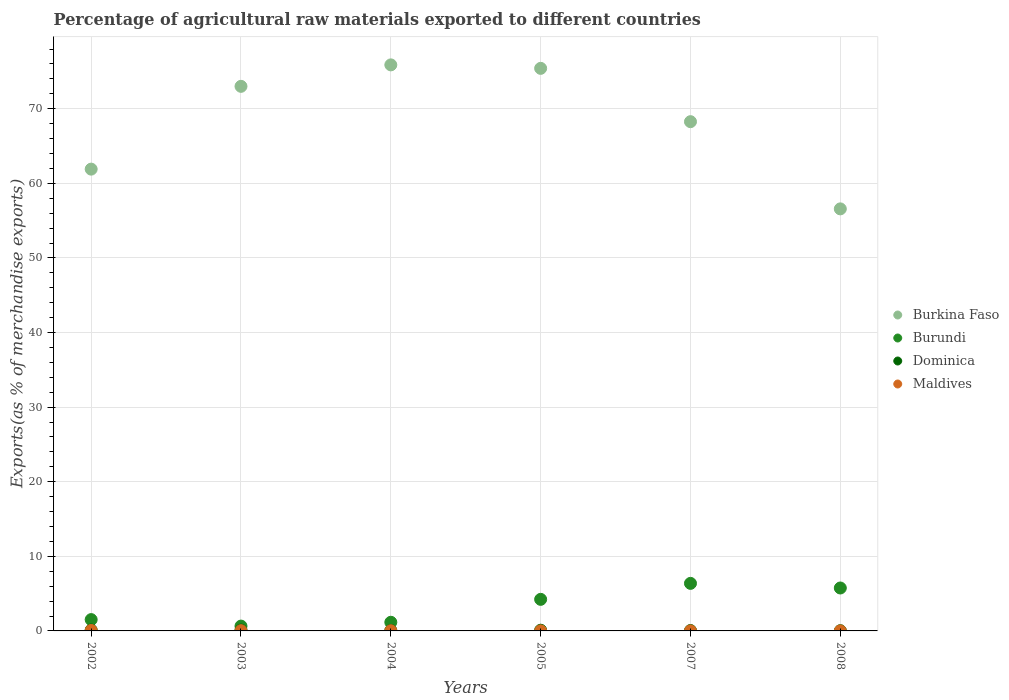What is the percentage of exports to different countries in Maldives in 2005?
Give a very brief answer. 0.01. Across all years, what is the maximum percentage of exports to different countries in Burundi?
Offer a very short reply. 6.37. Across all years, what is the minimum percentage of exports to different countries in Maldives?
Provide a succinct answer. 0. In which year was the percentage of exports to different countries in Maldives minimum?
Offer a terse response. 2008. What is the total percentage of exports to different countries in Burkina Faso in the graph?
Your answer should be very brief. 411.03. What is the difference between the percentage of exports to different countries in Dominica in 2003 and that in 2005?
Provide a succinct answer. 0.02. What is the difference between the percentage of exports to different countries in Burundi in 2004 and the percentage of exports to different countries in Dominica in 2008?
Provide a succinct answer. 1.13. What is the average percentage of exports to different countries in Burkina Faso per year?
Offer a very short reply. 68.51. In the year 2005, what is the difference between the percentage of exports to different countries in Dominica and percentage of exports to different countries in Maldives?
Provide a short and direct response. 0.09. What is the ratio of the percentage of exports to different countries in Maldives in 2005 to that in 2007?
Make the answer very short. 1.72. Is the percentage of exports to different countries in Burkina Faso in 2005 less than that in 2007?
Offer a terse response. No. What is the difference between the highest and the second highest percentage of exports to different countries in Burkina Faso?
Give a very brief answer. 0.47. What is the difference between the highest and the lowest percentage of exports to different countries in Dominica?
Offer a very short reply. 0.09. In how many years, is the percentage of exports to different countries in Burkina Faso greater than the average percentage of exports to different countries in Burkina Faso taken over all years?
Ensure brevity in your answer.  3. Is the sum of the percentage of exports to different countries in Maldives in 2002 and 2005 greater than the maximum percentage of exports to different countries in Dominica across all years?
Give a very brief answer. No. Is it the case that in every year, the sum of the percentage of exports to different countries in Burkina Faso and percentage of exports to different countries in Dominica  is greater than the sum of percentage of exports to different countries in Maldives and percentage of exports to different countries in Burundi?
Your answer should be compact. Yes. How many years are there in the graph?
Your response must be concise. 6. Does the graph contain any zero values?
Your response must be concise. No. Does the graph contain grids?
Give a very brief answer. Yes. Where does the legend appear in the graph?
Your response must be concise. Center right. What is the title of the graph?
Make the answer very short. Percentage of agricultural raw materials exported to different countries. What is the label or title of the Y-axis?
Your response must be concise. Exports(as % of merchandise exports). What is the Exports(as % of merchandise exports) of Burkina Faso in 2002?
Make the answer very short. 61.9. What is the Exports(as % of merchandise exports) of Burundi in 2002?
Ensure brevity in your answer.  1.52. What is the Exports(as % of merchandise exports) of Dominica in 2002?
Make the answer very short. 0.12. What is the Exports(as % of merchandise exports) in Maldives in 2002?
Offer a very short reply. 0.06. What is the Exports(as % of merchandise exports) of Burkina Faso in 2003?
Make the answer very short. 73. What is the Exports(as % of merchandise exports) in Burundi in 2003?
Offer a terse response. 0.65. What is the Exports(as % of merchandise exports) of Dominica in 2003?
Your response must be concise. 0.11. What is the Exports(as % of merchandise exports) of Maldives in 2003?
Offer a very short reply. 0.03. What is the Exports(as % of merchandise exports) in Burkina Faso in 2004?
Your answer should be very brief. 75.88. What is the Exports(as % of merchandise exports) of Burundi in 2004?
Ensure brevity in your answer.  1.16. What is the Exports(as % of merchandise exports) in Dominica in 2004?
Make the answer very short. 0.07. What is the Exports(as % of merchandise exports) in Maldives in 2004?
Make the answer very short. 0.03. What is the Exports(as % of merchandise exports) of Burkina Faso in 2005?
Provide a short and direct response. 75.41. What is the Exports(as % of merchandise exports) in Burundi in 2005?
Ensure brevity in your answer.  4.23. What is the Exports(as % of merchandise exports) of Dominica in 2005?
Provide a short and direct response. 0.09. What is the Exports(as % of merchandise exports) of Maldives in 2005?
Your answer should be very brief. 0.01. What is the Exports(as % of merchandise exports) in Burkina Faso in 2007?
Your answer should be compact. 68.26. What is the Exports(as % of merchandise exports) in Burundi in 2007?
Provide a succinct answer. 6.37. What is the Exports(as % of merchandise exports) of Dominica in 2007?
Your answer should be very brief. 0.05. What is the Exports(as % of merchandise exports) of Maldives in 2007?
Give a very brief answer. 0. What is the Exports(as % of merchandise exports) in Burkina Faso in 2008?
Give a very brief answer. 56.58. What is the Exports(as % of merchandise exports) in Burundi in 2008?
Your response must be concise. 5.75. What is the Exports(as % of merchandise exports) of Dominica in 2008?
Offer a terse response. 0.03. What is the Exports(as % of merchandise exports) of Maldives in 2008?
Provide a short and direct response. 0. Across all years, what is the maximum Exports(as % of merchandise exports) of Burkina Faso?
Your answer should be compact. 75.88. Across all years, what is the maximum Exports(as % of merchandise exports) in Burundi?
Your response must be concise. 6.37. Across all years, what is the maximum Exports(as % of merchandise exports) in Dominica?
Provide a succinct answer. 0.12. Across all years, what is the maximum Exports(as % of merchandise exports) in Maldives?
Provide a short and direct response. 0.06. Across all years, what is the minimum Exports(as % of merchandise exports) in Burkina Faso?
Your response must be concise. 56.58. Across all years, what is the minimum Exports(as % of merchandise exports) of Burundi?
Keep it short and to the point. 0.65. Across all years, what is the minimum Exports(as % of merchandise exports) in Dominica?
Your answer should be compact. 0.03. Across all years, what is the minimum Exports(as % of merchandise exports) in Maldives?
Ensure brevity in your answer.  0. What is the total Exports(as % of merchandise exports) in Burkina Faso in the graph?
Ensure brevity in your answer.  411.03. What is the total Exports(as % of merchandise exports) of Burundi in the graph?
Your answer should be very brief. 19.69. What is the total Exports(as % of merchandise exports) of Dominica in the graph?
Provide a succinct answer. 0.48. What is the total Exports(as % of merchandise exports) of Maldives in the graph?
Provide a short and direct response. 0.14. What is the difference between the Exports(as % of merchandise exports) in Burkina Faso in 2002 and that in 2003?
Keep it short and to the point. -11.1. What is the difference between the Exports(as % of merchandise exports) in Burundi in 2002 and that in 2003?
Your answer should be compact. 0.87. What is the difference between the Exports(as % of merchandise exports) in Dominica in 2002 and that in 2003?
Your answer should be compact. 0.01. What is the difference between the Exports(as % of merchandise exports) in Maldives in 2002 and that in 2003?
Your answer should be compact. 0.03. What is the difference between the Exports(as % of merchandise exports) in Burkina Faso in 2002 and that in 2004?
Make the answer very short. -13.98. What is the difference between the Exports(as % of merchandise exports) in Burundi in 2002 and that in 2004?
Your answer should be compact. 0.36. What is the difference between the Exports(as % of merchandise exports) of Dominica in 2002 and that in 2004?
Your response must be concise. 0.05. What is the difference between the Exports(as % of merchandise exports) of Maldives in 2002 and that in 2004?
Your answer should be very brief. 0.04. What is the difference between the Exports(as % of merchandise exports) in Burkina Faso in 2002 and that in 2005?
Offer a very short reply. -13.51. What is the difference between the Exports(as % of merchandise exports) in Burundi in 2002 and that in 2005?
Keep it short and to the point. -2.71. What is the difference between the Exports(as % of merchandise exports) in Dominica in 2002 and that in 2005?
Your answer should be compact. 0.03. What is the difference between the Exports(as % of merchandise exports) of Maldives in 2002 and that in 2005?
Offer a terse response. 0.06. What is the difference between the Exports(as % of merchandise exports) of Burkina Faso in 2002 and that in 2007?
Your answer should be compact. -6.36. What is the difference between the Exports(as % of merchandise exports) of Burundi in 2002 and that in 2007?
Offer a very short reply. -4.86. What is the difference between the Exports(as % of merchandise exports) in Dominica in 2002 and that in 2007?
Offer a terse response. 0.07. What is the difference between the Exports(as % of merchandise exports) of Maldives in 2002 and that in 2007?
Offer a terse response. 0.06. What is the difference between the Exports(as % of merchandise exports) in Burkina Faso in 2002 and that in 2008?
Provide a short and direct response. 5.33. What is the difference between the Exports(as % of merchandise exports) in Burundi in 2002 and that in 2008?
Provide a short and direct response. -4.24. What is the difference between the Exports(as % of merchandise exports) in Dominica in 2002 and that in 2008?
Give a very brief answer. 0.09. What is the difference between the Exports(as % of merchandise exports) of Maldives in 2002 and that in 2008?
Keep it short and to the point. 0.06. What is the difference between the Exports(as % of merchandise exports) in Burkina Faso in 2003 and that in 2004?
Make the answer very short. -2.88. What is the difference between the Exports(as % of merchandise exports) of Burundi in 2003 and that in 2004?
Ensure brevity in your answer.  -0.51. What is the difference between the Exports(as % of merchandise exports) in Dominica in 2003 and that in 2004?
Offer a very short reply. 0.05. What is the difference between the Exports(as % of merchandise exports) of Maldives in 2003 and that in 2004?
Keep it short and to the point. 0.01. What is the difference between the Exports(as % of merchandise exports) in Burkina Faso in 2003 and that in 2005?
Keep it short and to the point. -2.41. What is the difference between the Exports(as % of merchandise exports) of Burundi in 2003 and that in 2005?
Your answer should be very brief. -3.59. What is the difference between the Exports(as % of merchandise exports) of Dominica in 2003 and that in 2005?
Your answer should be very brief. 0.02. What is the difference between the Exports(as % of merchandise exports) of Maldives in 2003 and that in 2005?
Make the answer very short. 0.03. What is the difference between the Exports(as % of merchandise exports) in Burkina Faso in 2003 and that in 2007?
Provide a short and direct response. 4.74. What is the difference between the Exports(as % of merchandise exports) in Burundi in 2003 and that in 2007?
Keep it short and to the point. -5.73. What is the difference between the Exports(as % of merchandise exports) of Dominica in 2003 and that in 2007?
Offer a terse response. 0.06. What is the difference between the Exports(as % of merchandise exports) of Maldives in 2003 and that in 2007?
Your answer should be compact. 0.03. What is the difference between the Exports(as % of merchandise exports) of Burkina Faso in 2003 and that in 2008?
Ensure brevity in your answer.  16.43. What is the difference between the Exports(as % of merchandise exports) in Burundi in 2003 and that in 2008?
Offer a terse response. -5.11. What is the difference between the Exports(as % of merchandise exports) in Dominica in 2003 and that in 2008?
Your answer should be very brief. 0.08. What is the difference between the Exports(as % of merchandise exports) in Maldives in 2003 and that in 2008?
Ensure brevity in your answer.  0.03. What is the difference between the Exports(as % of merchandise exports) of Burkina Faso in 2004 and that in 2005?
Offer a terse response. 0.47. What is the difference between the Exports(as % of merchandise exports) of Burundi in 2004 and that in 2005?
Offer a terse response. -3.07. What is the difference between the Exports(as % of merchandise exports) of Dominica in 2004 and that in 2005?
Provide a short and direct response. -0.03. What is the difference between the Exports(as % of merchandise exports) in Maldives in 2004 and that in 2005?
Keep it short and to the point. 0.02. What is the difference between the Exports(as % of merchandise exports) in Burkina Faso in 2004 and that in 2007?
Give a very brief answer. 7.61. What is the difference between the Exports(as % of merchandise exports) in Burundi in 2004 and that in 2007?
Give a very brief answer. -5.22. What is the difference between the Exports(as % of merchandise exports) in Dominica in 2004 and that in 2007?
Your answer should be compact. 0.01. What is the difference between the Exports(as % of merchandise exports) in Maldives in 2004 and that in 2007?
Ensure brevity in your answer.  0.02. What is the difference between the Exports(as % of merchandise exports) in Burkina Faso in 2004 and that in 2008?
Your answer should be very brief. 19.3. What is the difference between the Exports(as % of merchandise exports) of Burundi in 2004 and that in 2008?
Give a very brief answer. -4.6. What is the difference between the Exports(as % of merchandise exports) of Dominica in 2004 and that in 2008?
Your answer should be compact. 0.04. What is the difference between the Exports(as % of merchandise exports) in Maldives in 2004 and that in 2008?
Provide a short and direct response. 0.03. What is the difference between the Exports(as % of merchandise exports) of Burkina Faso in 2005 and that in 2007?
Give a very brief answer. 7.15. What is the difference between the Exports(as % of merchandise exports) in Burundi in 2005 and that in 2007?
Provide a succinct answer. -2.14. What is the difference between the Exports(as % of merchandise exports) of Dominica in 2005 and that in 2007?
Your response must be concise. 0.04. What is the difference between the Exports(as % of merchandise exports) of Maldives in 2005 and that in 2007?
Provide a short and direct response. 0. What is the difference between the Exports(as % of merchandise exports) of Burkina Faso in 2005 and that in 2008?
Your response must be concise. 18.84. What is the difference between the Exports(as % of merchandise exports) in Burundi in 2005 and that in 2008?
Make the answer very short. -1.52. What is the difference between the Exports(as % of merchandise exports) in Dominica in 2005 and that in 2008?
Keep it short and to the point. 0.06. What is the difference between the Exports(as % of merchandise exports) of Maldives in 2005 and that in 2008?
Offer a terse response. 0.01. What is the difference between the Exports(as % of merchandise exports) in Burkina Faso in 2007 and that in 2008?
Your response must be concise. 11.69. What is the difference between the Exports(as % of merchandise exports) of Burundi in 2007 and that in 2008?
Your answer should be compact. 0.62. What is the difference between the Exports(as % of merchandise exports) of Dominica in 2007 and that in 2008?
Provide a short and direct response. 0.02. What is the difference between the Exports(as % of merchandise exports) of Maldives in 2007 and that in 2008?
Provide a short and direct response. 0. What is the difference between the Exports(as % of merchandise exports) of Burkina Faso in 2002 and the Exports(as % of merchandise exports) of Burundi in 2003?
Give a very brief answer. 61.26. What is the difference between the Exports(as % of merchandise exports) in Burkina Faso in 2002 and the Exports(as % of merchandise exports) in Dominica in 2003?
Offer a terse response. 61.79. What is the difference between the Exports(as % of merchandise exports) in Burkina Faso in 2002 and the Exports(as % of merchandise exports) in Maldives in 2003?
Make the answer very short. 61.87. What is the difference between the Exports(as % of merchandise exports) of Burundi in 2002 and the Exports(as % of merchandise exports) of Dominica in 2003?
Provide a short and direct response. 1.4. What is the difference between the Exports(as % of merchandise exports) in Burundi in 2002 and the Exports(as % of merchandise exports) in Maldives in 2003?
Give a very brief answer. 1.48. What is the difference between the Exports(as % of merchandise exports) of Dominica in 2002 and the Exports(as % of merchandise exports) of Maldives in 2003?
Your answer should be compact. 0.09. What is the difference between the Exports(as % of merchandise exports) in Burkina Faso in 2002 and the Exports(as % of merchandise exports) in Burundi in 2004?
Keep it short and to the point. 60.74. What is the difference between the Exports(as % of merchandise exports) in Burkina Faso in 2002 and the Exports(as % of merchandise exports) in Dominica in 2004?
Offer a very short reply. 61.84. What is the difference between the Exports(as % of merchandise exports) in Burkina Faso in 2002 and the Exports(as % of merchandise exports) in Maldives in 2004?
Ensure brevity in your answer.  61.88. What is the difference between the Exports(as % of merchandise exports) of Burundi in 2002 and the Exports(as % of merchandise exports) of Dominica in 2004?
Your answer should be very brief. 1.45. What is the difference between the Exports(as % of merchandise exports) of Burundi in 2002 and the Exports(as % of merchandise exports) of Maldives in 2004?
Ensure brevity in your answer.  1.49. What is the difference between the Exports(as % of merchandise exports) of Dominica in 2002 and the Exports(as % of merchandise exports) of Maldives in 2004?
Keep it short and to the point. 0.09. What is the difference between the Exports(as % of merchandise exports) in Burkina Faso in 2002 and the Exports(as % of merchandise exports) in Burundi in 2005?
Your answer should be very brief. 57.67. What is the difference between the Exports(as % of merchandise exports) of Burkina Faso in 2002 and the Exports(as % of merchandise exports) of Dominica in 2005?
Your answer should be very brief. 61.81. What is the difference between the Exports(as % of merchandise exports) of Burkina Faso in 2002 and the Exports(as % of merchandise exports) of Maldives in 2005?
Provide a short and direct response. 61.9. What is the difference between the Exports(as % of merchandise exports) of Burundi in 2002 and the Exports(as % of merchandise exports) of Dominica in 2005?
Make the answer very short. 1.42. What is the difference between the Exports(as % of merchandise exports) in Burundi in 2002 and the Exports(as % of merchandise exports) in Maldives in 2005?
Your response must be concise. 1.51. What is the difference between the Exports(as % of merchandise exports) in Dominica in 2002 and the Exports(as % of merchandise exports) in Maldives in 2005?
Ensure brevity in your answer.  0.11. What is the difference between the Exports(as % of merchandise exports) in Burkina Faso in 2002 and the Exports(as % of merchandise exports) in Burundi in 2007?
Offer a very short reply. 55.53. What is the difference between the Exports(as % of merchandise exports) in Burkina Faso in 2002 and the Exports(as % of merchandise exports) in Dominica in 2007?
Keep it short and to the point. 61.85. What is the difference between the Exports(as % of merchandise exports) of Burkina Faso in 2002 and the Exports(as % of merchandise exports) of Maldives in 2007?
Provide a short and direct response. 61.9. What is the difference between the Exports(as % of merchandise exports) in Burundi in 2002 and the Exports(as % of merchandise exports) in Dominica in 2007?
Offer a very short reply. 1.46. What is the difference between the Exports(as % of merchandise exports) of Burundi in 2002 and the Exports(as % of merchandise exports) of Maldives in 2007?
Offer a terse response. 1.51. What is the difference between the Exports(as % of merchandise exports) of Dominica in 2002 and the Exports(as % of merchandise exports) of Maldives in 2007?
Your answer should be compact. 0.12. What is the difference between the Exports(as % of merchandise exports) in Burkina Faso in 2002 and the Exports(as % of merchandise exports) in Burundi in 2008?
Ensure brevity in your answer.  56.15. What is the difference between the Exports(as % of merchandise exports) in Burkina Faso in 2002 and the Exports(as % of merchandise exports) in Dominica in 2008?
Keep it short and to the point. 61.87. What is the difference between the Exports(as % of merchandise exports) in Burkina Faso in 2002 and the Exports(as % of merchandise exports) in Maldives in 2008?
Offer a very short reply. 61.9. What is the difference between the Exports(as % of merchandise exports) in Burundi in 2002 and the Exports(as % of merchandise exports) in Dominica in 2008?
Your answer should be compact. 1.49. What is the difference between the Exports(as % of merchandise exports) in Burundi in 2002 and the Exports(as % of merchandise exports) in Maldives in 2008?
Your answer should be very brief. 1.52. What is the difference between the Exports(as % of merchandise exports) in Dominica in 2002 and the Exports(as % of merchandise exports) in Maldives in 2008?
Make the answer very short. 0.12. What is the difference between the Exports(as % of merchandise exports) of Burkina Faso in 2003 and the Exports(as % of merchandise exports) of Burundi in 2004?
Provide a succinct answer. 71.84. What is the difference between the Exports(as % of merchandise exports) in Burkina Faso in 2003 and the Exports(as % of merchandise exports) in Dominica in 2004?
Offer a very short reply. 72.94. What is the difference between the Exports(as % of merchandise exports) of Burkina Faso in 2003 and the Exports(as % of merchandise exports) of Maldives in 2004?
Provide a short and direct response. 72.97. What is the difference between the Exports(as % of merchandise exports) of Burundi in 2003 and the Exports(as % of merchandise exports) of Dominica in 2004?
Your response must be concise. 0.58. What is the difference between the Exports(as % of merchandise exports) in Burundi in 2003 and the Exports(as % of merchandise exports) in Maldives in 2004?
Your answer should be compact. 0.62. What is the difference between the Exports(as % of merchandise exports) of Dominica in 2003 and the Exports(as % of merchandise exports) of Maldives in 2004?
Offer a terse response. 0.09. What is the difference between the Exports(as % of merchandise exports) of Burkina Faso in 2003 and the Exports(as % of merchandise exports) of Burundi in 2005?
Your answer should be very brief. 68.77. What is the difference between the Exports(as % of merchandise exports) of Burkina Faso in 2003 and the Exports(as % of merchandise exports) of Dominica in 2005?
Provide a short and direct response. 72.91. What is the difference between the Exports(as % of merchandise exports) in Burkina Faso in 2003 and the Exports(as % of merchandise exports) in Maldives in 2005?
Offer a very short reply. 72.99. What is the difference between the Exports(as % of merchandise exports) of Burundi in 2003 and the Exports(as % of merchandise exports) of Dominica in 2005?
Keep it short and to the point. 0.55. What is the difference between the Exports(as % of merchandise exports) of Burundi in 2003 and the Exports(as % of merchandise exports) of Maldives in 2005?
Your answer should be very brief. 0.64. What is the difference between the Exports(as % of merchandise exports) in Dominica in 2003 and the Exports(as % of merchandise exports) in Maldives in 2005?
Offer a terse response. 0.11. What is the difference between the Exports(as % of merchandise exports) in Burkina Faso in 2003 and the Exports(as % of merchandise exports) in Burundi in 2007?
Your response must be concise. 66.63. What is the difference between the Exports(as % of merchandise exports) in Burkina Faso in 2003 and the Exports(as % of merchandise exports) in Dominica in 2007?
Your answer should be very brief. 72.95. What is the difference between the Exports(as % of merchandise exports) of Burkina Faso in 2003 and the Exports(as % of merchandise exports) of Maldives in 2007?
Offer a very short reply. 73. What is the difference between the Exports(as % of merchandise exports) of Burundi in 2003 and the Exports(as % of merchandise exports) of Dominica in 2007?
Your response must be concise. 0.59. What is the difference between the Exports(as % of merchandise exports) in Burundi in 2003 and the Exports(as % of merchandise exports) in Maldives in 2007?
Keep it short and to the point. 0.64. What is the difference between the Exports(as % of merchandise exports) in Dominica in 2003 and the Exports(as % of merchandise exports) in Maldives in 2007?
Your answer should be compact. 0.11. What is the difference between the Exports(as % of merchandise exports) in Burkina Faso in 2003 and the Exports(as % of merchandise exports) in Burundi in 2008?
Give a very brief answer. 67.25. What is the difference between the Exports(as % of merchandise exports) of Burkina Faso in 2003 and the Exports(as % of merchandise exports) of Dominica in 2008?
Give a very brief answer. 72.97. What is the difference between the Exports(as % of merchandise exports) in Burkina Faso in 2003 and the Exports(as % of merchandise exports) in Maldives in 2008?
Your answer should be very brief. 73. What is the difference between the Exports(as % of merchandise exports) of Burundi in 2003 and the Exports(as % of merchandise exports) of Dominica in 2008?
Provide a short and direct response. 0.62. What is the difference between the Exports(as % of merchandise exports) in Burundi in 2003 and the Exports(as % of merchandise exports) in Maldives in 2008?
Keep it short and to the point. 0.65. What is the difference between the Exports(as % of merchandise exports) in Dominica in 2003 and the Exports(as % of merchandise exports) in Maldives in 2008?
Offer a terse response. 0.11. What is the difference between the Exports(as % of merchandise exports) of Burkina Faso in 2004 and the Exports(as % of merchandise exports) of Burundi in 2005?
Offer a terse response. 71.65. What is the difference between the Exports(as % of merchandise exports) in Burkina Faso in 2004 and the Exports(as % of merchandise exports) in Dominica in 2005?
Offer a terse response. 75.78. What is the difference between the Exports(as % of merchandise exports) in Burkina Faso in 2004 and the Exports(as % of merchandise exports) in Maldives in 2005?
Keep it short and to the point. 75.87. What is the difference between the Exports(as % of merchandise exports) in Burundi in 2004 and the Exports(as % of merchandise exports) in Dominica in 2005?
Keep it short and to the point. 1.07. What is the difference between the Exports(as % of merchandise exports) of Burundi in 2004 and the Exports(as % of merchandise exports) of Maldives in 2005?
Offer a terse response. 1.15. What is the difference between the Exports(as % of merchandise exports) of Dominica in 2004 and the Exports(as % of merchandise exports) of Maldives in 2005?
Provide a short and direct response. 0.06. What is the difference between the Exports(as % of merchandise exports) of Burkina Faso in 2004 and the Exports(as % of merchandise exports) of Burundi in 2007?
Your answer should be very brief. 69.5. What is the difference between the Exports(as % of merchandise exports) in Burkina Faso in 2004 and the Exports(as % of merchandise exports) in Dominica in 2007?
Offer a terse response. 75.82. What is the difference between the Exports(as % of merchandise exports) in Burkina Faso in 2004 and the Exports(as % of merchandise exports) in Maldives in 2007?
Offer a very short reply. 75.87. What is the difference between the Exports(as % of merchandise exports) of Burundi in 2004 and the Exports(as % of merchandise exports) of Dominica in 2007?
Your answer should be very brief. 1.1. What is the difference between the Exports(as % of merchandise exports) of Burundi in 2004 and the Exports(as % of merchandise exports) of Maldives in 2007?
Keep it short and to the point. 1.15. What is the difference between the Exports(as % of merchandise exports) in Dominica in 2004 and the Exports(as % of merchandise exports) in Maldives in 2007?
Offer a terse response. 0.06. What is the difference between the Exports(as % of merchandise exports) of Burkina Faso in 2004 and the Exports(as % of merchandise exports) of Burundi in 2008?
Ensure brevity in your answer.  70.12. What is the difference between the Exports(as % of merchandise exports) in Burkina Faso in 2004 and the Exports(as % of merchandise exports) in Dominica in 2008?
Ensure brevity in your answer.  75.85. What is the difference between the Exports(as % of merchandise exports) in Burkina Faso in 2004 and the Exports(as % of merchandise exports) in Maldives in 2008?
Your answer should be compact. 75.88. What is the difference between the Exports(as % of merchandise exports) in Burundi in 2004 and the Exports(as % of merchandise exports) in Dominica in 2008?
Ensure brevity in your answer.  1.13. What is the difference between the Exports(as % of merchandise exports) of Burundi in 2004 and the Exports(as % of merchandise exports) of Maldives in 2008?
Your answer should be compact. 1.16. What is the difference between the Exports(as % of merchandise exports) of Dominica in 2004 and the Exports(as % of merchandise exports) of Maldives in 2008?
Your answer should be compact. 0.06. What is the difference between the Exports(as % of merchandise exports) of Burkina Faso in 2005 and the Exports(as % of merchandise exports) of Burundi in 2007?
Offer a very short reply. 69.04. What is the difference between the Exports(as % of merchandise exports) in Burkina Faso in 2005 and the Exports(as % of merchandise exports) in Dominica in 2007?
Offer a very short reply. 75.36. What is the difference between the Exports(as % of merchandise exports) in Burkina Faso in 2005 and the Exports(as % of merchandise exports) in Maldives in 2007?
Give a very brief answer. 75.41. What is the difference between the Exports(as % of merchandise exports) of Burundi in 2005 and the Exports(as % of merchandise exports) of Dominica in 2007?
Ensure brevity in your answer.  4.18. What is the difference between the Exports(as % of merchandise exports) in Burundi in 2005 and the Exports(as % of merchandise exports) in Maldives in 2007?
Offer a very short reply. 4.23. What is the difference between the Exports(as % of merchandise exports) in Dominica in 2005 and the Exports(as % of merchandise exports) in Maldives in 2007?
Offer a very short reply. 0.09. What is the difference between the Exports(as % of merchandise exports) in Burkina Faso in 2005 and the Exports(as % of merchandise exports) in Burundi in 2008?
Offer a terse response. 69.66. What is the difference between the Exports(as % of merchandise exports) of Burkina Faso in 2005 and the Exports(as % of merchandise exports) of Dominica in 2008?
Keep it short and to the point. 75.38. What is the difference between the Exports(as % of merchandise exports) in Burkina Faso in 2005 and the Exports(as % of merchandise exports) in Maldives in 2008?
Keep it short and to the point. 75.41. What is the difference between the Exports(as % of merchandise exports) of Burundi in 2005 and the Exports(as % of merchandise exports) of Dominica in 2008?
Give a very brief answer. 4.2. What is the difference between the Exports(as % of merchandise exports) of Burundi in 2005 and the Exports(as % of merchandise exports) of Maldives in 2008?
Your response must be concise. 4.23. What is the difference between the Exports(as % of merchandise exports) of Dominica in 2005 and the Exports(as % of merchandise exports) of Maldives in 2008?
Ensure brevity in your answer.  0.09. What is the difference between the Exports(as % of merchandise exports) in Burkina Faso in 2007 and the Exports(as % of merchandise exports) in Burundi in 2008?
Give a very brief answer. 62.51. What is the difference between the Exports(as % of merchandise exports) of Burkina Faso in 2007 and the Exports(as % of merchandise exports) of Dominica in 2008?
Make the answer very short. 68.23. What is the difference between the Exports(as % of merchandise exports) of Burkina Faso in 2007 and the Exports(as % of merchandise exports) of Maldives in 2008?
Your response must be concise. 68.26. What is the difference between the Exports(as % of merchandise exports) of Burundi in 2007 and the Exports(as % of merchandise exports) of Dominica in 2008?
Offer a terse response. 6.34. What is the difference between the Exports(as % of merchandise exports) in Burundi in 2007 and the Exports(as % of merchandise exports) in Maldives in 2008?
Make the answer very short. 6.37. What is the difference between the Exports(as % of merchandise exports) of Dominica in 2007 and the Exports(as % of merchandise exports) of Maldives in 2008?
Ensure brevity in your answer.  0.05. What is the average Exports(as % of merchandise exports) in Burkina Faso per year?
Give a very brief answer. 68.51. What is the average Exports(as % of merchandise exports) in Burundi per year?
Ensure brevity in your answer.  3.28. What is the average Exports(as % of merchandise exports) in Dominica per year?
Offer a terse response. 0.08. What is the average Exports(as % of merchandise exports) of Maldives per year?
Provide a succinct answer. 0.02. In the year 2002, what is the difference between the Exports(as % of merchandise exports) of Burkina Faso and Exports(as % of merchandise exports) of Burundi?
Provide a short and direct response. 60.38. In the year 2002, what is the difference between the Exports(as % of merchandise exports) in Burkina Faso and Exports(as % of merchandise exports) in Dominica?
Give a very brief answer. 61.78. In the year 2002, what is the difference between the Exports(as % of merchandise exports) of Burkina Faso and Exports(as % of merchandise exports) of Maldives?
Offer a terse response. 61.84. In the year 2002, what is the difference between the Exports(as % of merchandise exports) in Burundi and Exports(as % of merchandise exports) in Dominica?
Ensure brevity in your answer.  1.4. In the year 2002, what is the difference between the Exports(as % of merchandise exports) of Burundi and Exports(as % of merchandise exports) of Maldives?
Give a very brief answer. 1.45. In the year 2002, what is the difference between the Exports(as % of merchandise exports) in Dominica and Exports(as % of merchandise exports) in Maldives?
Your answer should be compact. 0.06. In the year 2003, what is the difference between the Exports(as % of merchandise exports) in Burkina Faso and Exports(as % of merchandise exports) in Burundi?
Keep it short and to the point. 72.35. In the year 2003, what is the difference between the Exports(as % of merchandise exports) of Burkina Faso and Exports(as % of merchandise exports) of Dominica?
Offer a very short reply. 72.89. In the year 2003, what is the difference between the Exports(as % of merchandise exports) in Burkina Faso and Exports(as % of merchandise exports) in Maldives?
Provide a succinct answer. 72.97. In the year 2003, what is the difference between the Exports(as % of merchandise exports) of Burundi and Exports(as % of merchandise exports) of Dominica?
Your response must be concise. 0.53. In the year 2003, what is the difference between the Exports(as % of merchandise exports) in Burundi and Exports(as % of merchandise exports) in Maldives?
Make the answer very short. 0.61. In the year 2003, what is the difference between the Exports(as % of merchandise exports) in Dominica and Exports(as % of merchandise exports) in Maldives?
Keep it short and to the point. 0.08. In the year 2004, what is the difference between the Exports(as % of merchandise exports) of Burkina Faso and Exports(as % of merchandise exports) of Burundi?
Your response must be concise. 74.72. In the year 2004, what is the difference between the Exports(as % of merchandise exports) of Burkina Faso and Exports(as % of merchandise exports) of Dominica?
Your answer should be very brief. 75.81. In the year 2004, what is the difference between the Exports(as % of merchandise exports) of Burkina Faso and Exports(as % of merchandise exports) of Maldives?
Offer a very short reply. 75.85. In the year 2004, what is the difference between the Exports(as % of merchandise exports) of Burundi and Exports(as % of merchandise exports) of Dominica?
Your response must be concise. 1.09. In the year 2004, what is the difference between the Exports(as % of merchandise exports) of Burundi and Exports(as % of merchandise exports) of Maldives?
Keep it short and to the point. 1.13. In the year 2004, what is the difference between the Exports(as % of merchandise exports) in Dominica and Exports(as % of merchandise exports) in Maldives?
Keep it short and to the point. 0.04. In the year 2005, what is the difference between the Exports(as % of merchandise exports) of Burkina Faso and Exports(as % of merchandise exports) of Burundi?
Offer a very short reply. 71.18. In the year 2005, what is the difference between the Exports(as % of merchandise exports) of Burkina Faso and Exports(as % of merchandise exports) of Dominica?
Offer a very short reply. 75.32. In the year 2005, what is the difference between the Exports(as % of merchandise exports) of Burkina Faso and Exports(as % of merchandise exports) of Maldives?
Offer a terse response. 75.41. In the year 2005, what is the difference between the Exports(as % of merchandise exports) of Burundi and Exports(as % of merchandise exports) of Dominica?
Offer a terse response. 4.14. In the year 2005, what is the difference between the Exports(as % of merchandise exports) in Burundi and Exports(as % of merchandise exports) in Maldives?
Your answer should be very brief. 4.22. In the year 2005, what is the difference between the Exports(as % of merchandise exports) in Dominica and Exports(as % of merchandise exports) in Maldives?
Give a very brief answer. 0.09. In the year 2007, what is the difference between the Exports(as % of merchandise exports) in Burkina Faso and Exports(as % of merchandise exports) in Burundi?
Offer a very short reply. 61.89. In the year 2007, what is the difference between the Exports(as % of merchandise exports) of Burkina Faso and Exports(as % of merchandise exports) of Dominica?
Your response must be concise. 68.21. In the year 2007, what is the difference between the Exports(as % of merchandise exports) in Burkina Faso and Exports(as % of merchandise exports) in Maldives?
Keep it short and to the point. 68.26. In the year 2007, what is the difference between the Exports(as % of merchandise exports) of Burundi and Exports(as % of merchandise exports) of Dominica?
Ensure brevity in your answer.  6.32. In the year 2007, what is the difference between the Exports(as % of merchandise exports) of Burundi and Exports(as % of merchandise exports) of Maldives?
Give a very brief answer. 6.37. In the year 2007, what is the difference between the Exports(as % of merchandise exports) of Dominica and Exports(as % of merchandise exports) of Maldives?
Provide a short and direct response. 0.05. In the year 2008, what is the difference between the Exports(as % of merchandise exports) in Burkina Faso and Exports(as % of merchandise exports) in Burundi?
Your answer should be compact. 50.82. In the year 2008, what is the difference between the Exports(as % of merchandise exports) of Burkina Faso and Exports(as % of merchandise exports) of Dominica?
Give a very brief answer. 56.55. In the year 2008, what is the difference between the Exports(as % of merchandise exports) in Burkina Faso and Exports(as % of merchandise exports) in Maldives?
Offer a terse response. 56.57. In the year 2008, what is the difference between the Exports(as % of merchandise exports) of Burundi and Exports(as % of merchandise exports) of Dominica?
Ensure brevity in your answer.  5.72. In the year 2008, what is the difference between the Exports(as % of merchandise exports) of Burundi and Exports(as % of merchandise exports) of Maldives?
Offer a very short reply. 5.75. In the year 2008, what is the difference between the Exports(as % of merchandise exports) in Dominica and Exports(as % of merchandise exports) in Maldives?
Offer a very short reply. 0.03. What is the ratio of the Exports(as % of merchandise exports) of Burkina Faso in 2002 to that in 2003?
Offer a terse response. 0.85. What is the ratio of the Exports(as % of merchandise exports) in Burundi in 2002 to that in 2003?
Ensure brevity in your answer.  2.35. What is the ratio of the Exports(as % of merchandise exports) of Dominica in 2002 to that in 2003?
Make the answer very short. 1.06. What is the ratio of the Exports(as % of merchandise exports) of Maldives in 2002 to that in 2003?
Your answer should be compact. 1.84. What is the ratio of the Exports(as % of merchandise exports) in Burkina Faso in 2002 to that in 2004?
Offer a terse response. 0.82. What is the ratio of the Exports(as % of merchandise exports) in Burundi in 2002 to that in 2004?
Offer a very short reply. 1.31. What is the ratio of the Exports(as % of merchandise exports) of Dominica in 2002 to that in 2004?
Provide a short and direct response. 1.84. What is the ratio of the Exports(as % of merchandise exports) of Maldives in 2002 to that in 2004?
Provide a succinct answer. 2.4. What is the ratio of the Exports(as % of merchandise exports) of Burkina Faso in 2002 to that in 2005?
Your response must be concise. 0.82. What is the ratio of the Exports(as % of merchandise exports) of Burundi in 2002 to that in 2005?
Your answer should be very brief. 0.36. What is the ratio of the Exports(as % of merchandise exports) of Dominica in 2002 to that in 2005?
Give a very brief answer. 1.28. What is the ratio of the Exports(as % of merchandise exports) of Maldives in 2002 to that in 2005?
Your response must be concise. 8.76. What is the ratio of the Exports(as % of merchandise exports) of Burkina Faso in 2002 to that in 2007?
Provide a succinct answer. 0.91. What is the ratio of the Exports(as % of merchandise exports) of Burundi in 2002 to that in 2007?
Your response must be concise. 0.24. What is the ratio of the Exports(as % of merchandise exports) in Dominica in 2002 to that in 2007?
Give a very brief answer. 2.21. What is the ratio of the Exports(as % of merchandise exports) of Maldives in 2002 to that in 2007?
Make the answer very short. 15.04. What is the ratio of the Exports(as % of merchandise exports) in Burkina Faso in 2002 to that in 2008?
Provide a succinct answer. 1.09. What is the ratio of the Exports(as % of merchandise exports) of Burundi in 2002 to that in 2008?
Ensure brevity in your answer.  0.26. What is the ratio of the Exports(as % of merchandise exports) in Dominica in 2002 to that in 2008?
Make the answer very short. 3.96. What is the ratio of the Exports(as % of merchandise exports) of Maldives in 2002 to that in 2008?
Keep it short and to the point. 70.58. What is the ratio of the Exports(as % of merchandise exports) of Burkina Faso in 2003 to that in 2004?
Your response must be concise. 0.96. What is the ratio of the Exports(as % of merchandise exports) of Burundi in 2003 to that in 2004?
Provide a succinct answer. 0.56. What is the ratio of the Exports(as % of merchandise exports) in Dominica in 2003 to that in 2004?
Your answer should be very brief. 1.74. What is the ratio of the Exports(as % of merchandise exports) in Maldives in 2003 to that in 2004?
Ensure brevity in your answer.  1.3. What is the ratio of the Exports(as % of merchandise exports) of Burundi in 2003 to that in 2005?
Offer a terse response. 0.15. What is the ratio of the Exports(as % of merchandise exports) in Dominica in 2003 to that in 2005?
Offer a very short reply. 1.21. What is the ratio of the Exports(as % of merchandise exports) of Maldives in 2003 to that in 2005?
Make the answer very short. 4.75. What is the ratio of the Exports(as % of merchandise exports) in Burkina Faso in 2003 to that in 2007?
Offer a very short reply. 1.07. What is the ratio of the Exports(as % of merchandise exports) of Burundi in 2003 to that in 2007?
Give a very brief answer. 0.1. What is the ratio of the Exports(as % of merchandise exports) of Dominica in 2003 to that in 2007?
Offer a very short reply. 2.09. What is the ratio of the Exports(as % of merchandise exports) in Maldives in 2003 to that in 2007?
Make the answer very short. 8.16. What is the ratio of the Exports(as % of merchandise exports) in Burkina Faso in 2003 to that in 2008?
Give a very brief answer. 1.29. What is the ratio of the Exports(as % of merchandise exports) in Burundi in 2003 to that in 2008?
Give a very brief answer. 0.11. What is the ratio of the Exports(as % of merchandise exports) of Dominica in 2003 to that in 2008?
Make the answer very short. 3.74. What is the ratio of the Exports(as % of merchandise exports) of Maldives in 2003 to that in 2008?
Provide a short and direct response. 38.27. What is the ratio of the Exports(as % of merchandise exports) of Burundi in 2004 to that in 2005?
Your response must be concise. 0.27. What is the ratio of the Exports(as % of merchandise exports) of Dominica in 2004 to that in 2005?
Make the answer very short. 0.7. What is the ratio of the Exports(as % of merchandise exports) in Maldives in 2004 to that in 2005?
Provide a short and direct response. 3.64. What is the ratio of the Exports(as % of merchandise exports) in Burkina Faso in 2004 to that in 2007?
Provide a short and direct response. 1.11. What is the ratio of the Exports(as % of merchandise exports) in Burundi in 2004 to that in 2007?
Provide a short and direct response. 0.18. What is the ratio of the Exports(as % of merchandise exports) in Dominica in 2004 to that in 2007?
Ensure brevity in your answer.  1.21. What is the ratio of the Exports(as % of merchandise exports) of Maldives in 2004 to that in 2007?
Offer a very short reply. 6.26. What is the ratio of the Exports(as % of merchandise exports) in Burkina Faso in 2004 to that in 2008?
Make the answer very short. 1.34. What is the ratio of the Exports(as % of merchandise exports) in Burundi in 2004 to that in 2008?
Provide a short and direct response. 0.2. What is the ratio of the Exports(as % of merchandise exports) in Dominica in 2004 to that in 2008?
Provide a short and direct response. 2.15. What is the ratio of the Exports(as % of merchandise exports) in Maldives in 2004 to that in 2008?
Provide a succinct answer. 29.37. What is the ratio of the Exports(as % of merchandise exports) in Burkina Faso in 2005 to that in 2007?
Make the answer very short. 1.1. What is the ratio of the Exports(as % of merchandise exports) in Burundi in 2005 to that in 2007?
Your answer should be very brief. 0.66. What is the ratio of the Exports(as % of merchandise exports) of Dominica in 2005 to that in 2007?
Ensure brevity in your answer.  1.73. What is the ratio of the Exports(as % of merchandise exports) of Maldives in 2005 to that in 2007?
Offer a terse response. 1.72. What is the ratio of the Exports(as % of merchandise exports) in Burkina Faso in 2005 to that in 2008?
Your response must be concise. 1.33. What is the ratio of the Exports(as % of merchandise exports) of Burundi in 2005 to that in 2008?
Your answer should be very brief. 0.74. What is the ratio of the Exports(as % of merchandise exports) in Dominica in 2005 to that in 2008?
Offer a very short reply. 3.09. What is the ratio of the Exports(as % of merchandise exports) in Maldives in 2005 to that in 2008?
Ensure brevity in your answer.  8.06. What is the ratio of the Exports(as % of merchandise exports) of Burkina Faso in 2007 to that in 2008?
Keep it short and to the point. 1.21. What is the ratio of the Exports(as % of merchandise exports) in Burundi in 2007 to that in 2008?
Your response must be concise. 1.11. What is the ratio of the Exports(as % of merchandise exports) in Dominica in 2007 to that in 2008?
Offer a very short reply. 1.79. What is the ratio of the Exports(as % of merchandise exports) of Maldives in 2007 to that in 2008?
Provide a succinct answer. 4.69. What is the difference between the highest and the second highest Exports(as % of merchandise exports) in Burkina Faso?
Give a very brief answer. 0.47. What is the difference between the highest and the second highest Exports(as % of merchandise exports) of Burundi?
Your answer should be very brief. 0.62. What is the difference between the highest and the second highest Exports(as % of merchandise exports) in Dominica?
Make the answer very short. 0.01. What is the difference between the highest and the second highest Exports(as % of merchandise exports) in Maldives?
Provide a succinct answer. 0.03. What is the difference between the highest and the lowest Exports(as % of merchandise exports) of Burkina Faso?
Offer a terse response. 19.3. What is the difference between the highest and the lowest Exports(as % of merchandise exports) of Burundi?
Your answer should be very brief. 5.73. What is the difference between the highest and the lowest Exports(as % of merchandise exports) of Dominica?
Provide a succinct answer. 0.09. What is the difference between the highest and the lowest Exports(as % of merchandise exports) of Maldives?
Offer a very short reply. 0.06. 